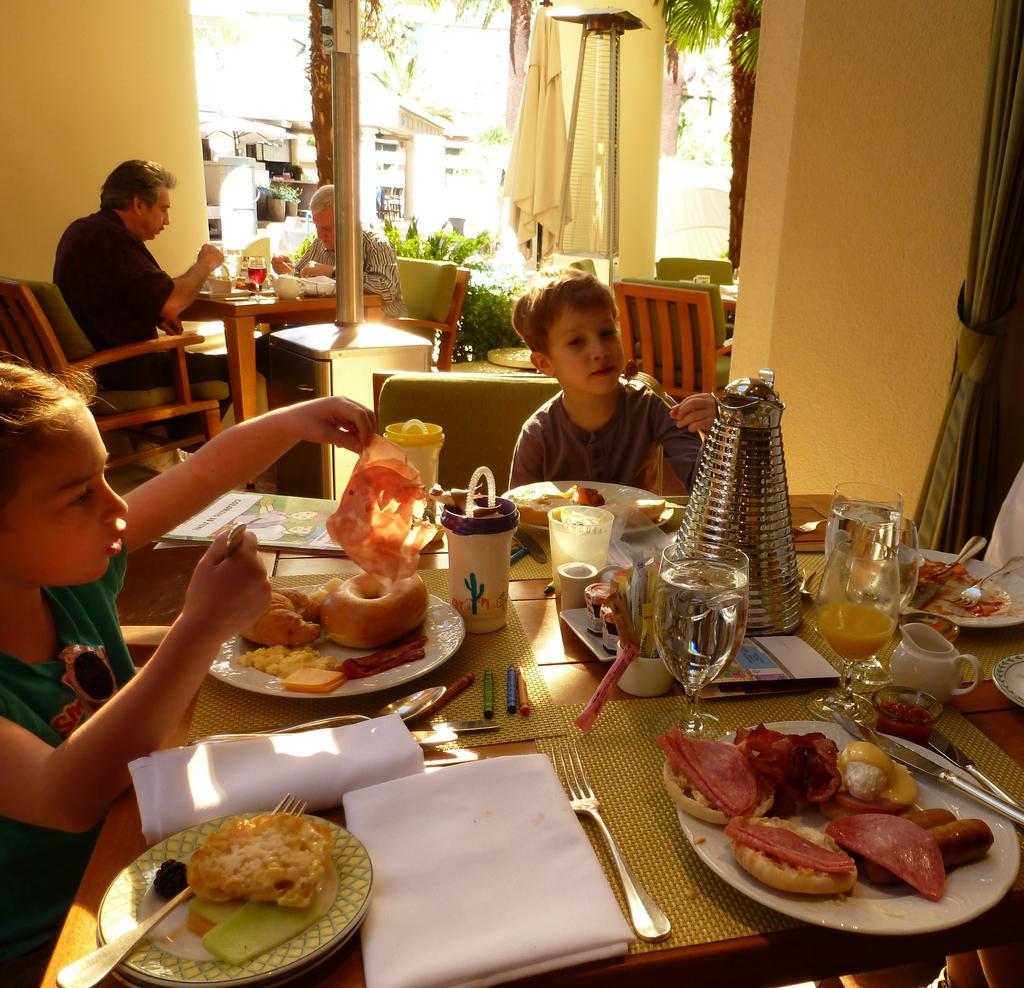Describe this image in one or two sentences. Here we can see a couple of children sitting on chairs with a table in front of them having food and there are also couple of men sitting on chairs with table in front of them 